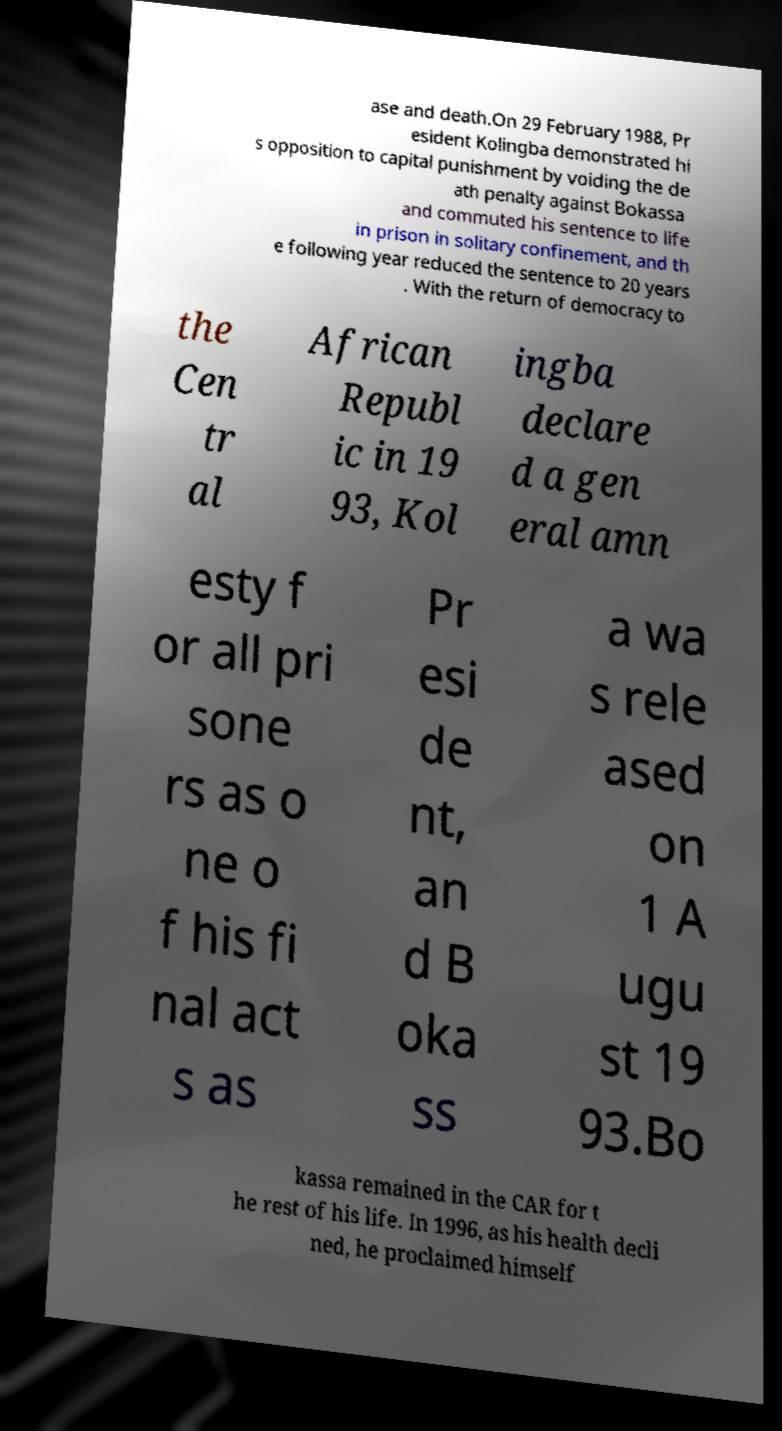What messages or text are displayed in this image? I need them in a readable, typed format. ase and death.On 29 February 1988, Pr esident Kolingba demonstrated hi s opposition to capital punishment by voiding the de ath penalty against Bokassa and commuted his sentence to life in prison in solitary confinement, and th e following year reduced the sentence to 20 years . With the return of democracy to the Cen tr al African Republ ic in 19 93, Kol ingba declare d a gen eral amn esty f or all pri sone rs as o ne o f his fi nal act s as Pr esi de nt, an d B oka ss a wa s rele ased on 1 A ugu st 19 93.Bo kassa remained in the CAR for t he rest of his life. In 1996, as his health decli ned, he proclaimed himself 